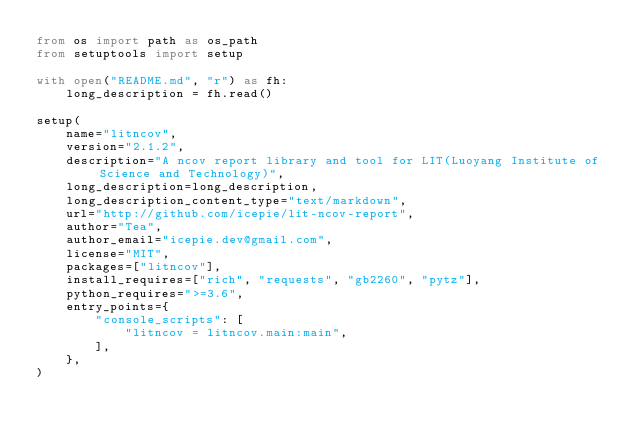Convert code to text. <code><loc_0><loc_0><loc_500><loc_500><_Python_>from os import path as os_path
from setuptools import setup

with open("README.md", "r") as fh:
    long_description = fh.read()

setup(
    name="litncov",
    version="2.1.2",
    description="A ncov report library and tool for LIT(Luoyang Institute of Science and Technology)",
    long_description=long_description,
    long_description_content_type="text/markdown",
    url="http://github.com/icepie/lit-ncov-report",
    author="Tea",
    author_email="icepie.dev@gmail.com",
    license="MIT",
    packages=["litncov"],
    install_requires=["rich", "requests", "gb2260", "pytz"],
    python_requires=">=3.6",
    entry_points={
        "console_scripts": [
            "litncov = litncov.main:main",
        ],
    },
)
</code> 